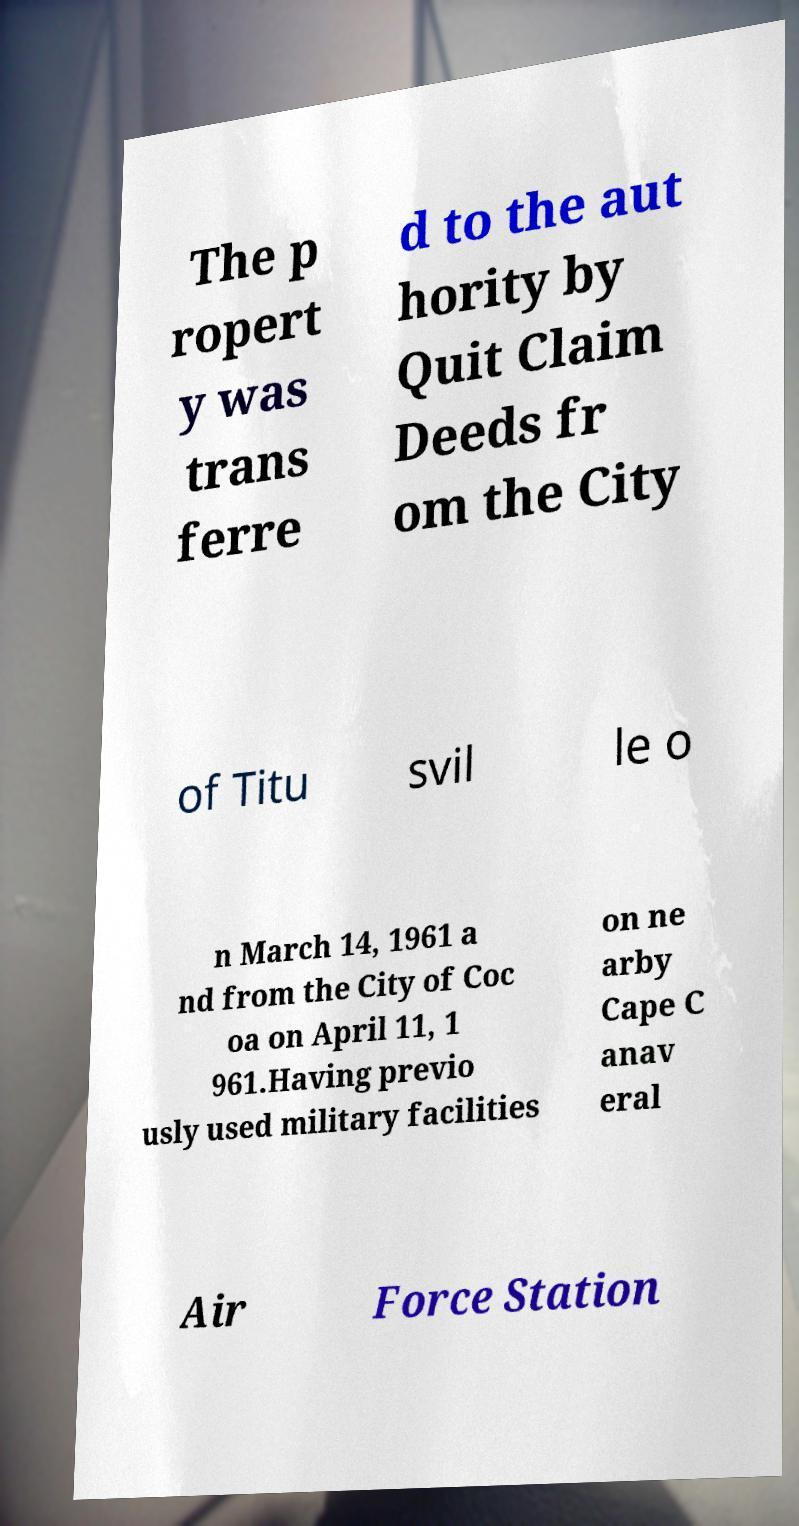Can you read and provide the text displayed in the image?This photo seems to have some interesting text. Can you extract and type it out for me? The p ropert y was trans ferre d to the aut hority by Quit Claim Deeds fr om the City of Titu svil le o n March 14, 1961 a nd from the City of Coc oa on April 11, 1 961.Having previo usly used military facilities on ne arby Cape C anav eral Air Force Station 